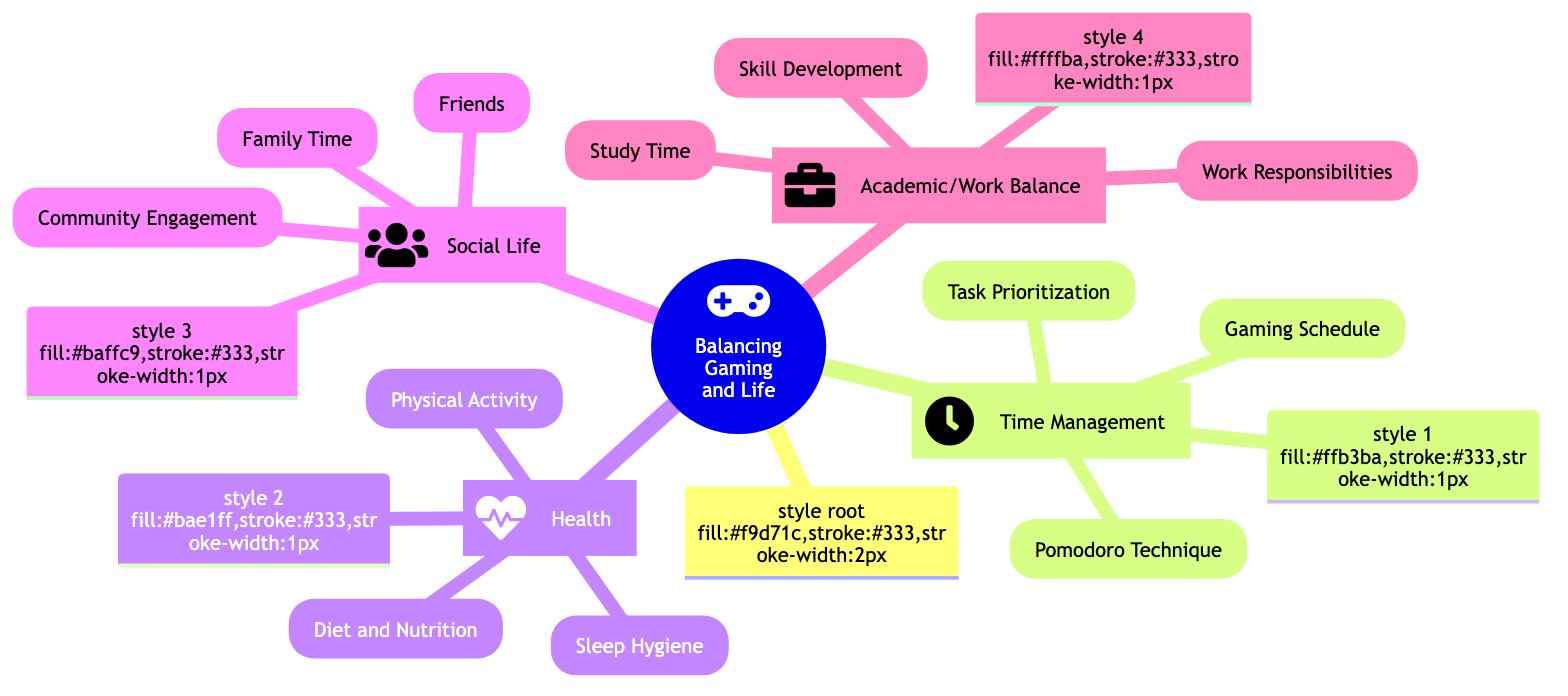What is the first main branch of the diagram? The first main branch in the diagram is "Time Management," which is the first node connected directly to the root.
Answer: Time Management How many sub-branches does "Health" have? The "Health" branch contains three sub-branches: Physical Activity, Sleep Hygiene, and Diet and Nutrition.
Answer: 3 What technique is suggested under the "Time Management" branch? Under "Time Management," the suggested technique is the "Pomodoro Technique." This can be identified as one of the three sub-nodes under the Time Management branch.
Answer: Pomodoro Technique What activity is recommended to stay fit? The diagram suggests incorporating "Physical Activity," which includes exercises like running or gym workouts as part of maintaining health.
Answer: Physical Activity Which branch focuses on improving study habits? The "Academic/Work Balance" branch focuses on improving study habits, specifically through "Study Time." It suggests allocating uninterrupted study periods for better focus.
Answer: Academic/Work Balance How should family time be spent according to the diagram? According to the diagram, family time can be spent by scheduling regular "family dinners or game nights" to bond with family members, as mentioned in the Social Life branch.
Answer: Family dinners or game nights What is the purpose of "Skill Development" under the Academic/Work Balance branch? "Skill Development" is aimed at pursuing activities like coding, language learning, or certification courses relevant to future goals, which enhances personal growth and preparedness for future challenges.
Answer: Skill Development What is advised for maintaining a consistent sleep schedule? The diagram advises maintaining "Sleep Hygiene" in the Health branch, which emphasizes aiming for 7-8 hours of sleep per night.
Answer: Sleep Hygiene What tool is mentioned for task prioritization? The tool mentioned for task prioritization under the Time Management branch is "Trello or Microsoft To-Do," used for organizing and prioritizing tasks efficiently.
Answer: Trello or Microsoft To-Do 